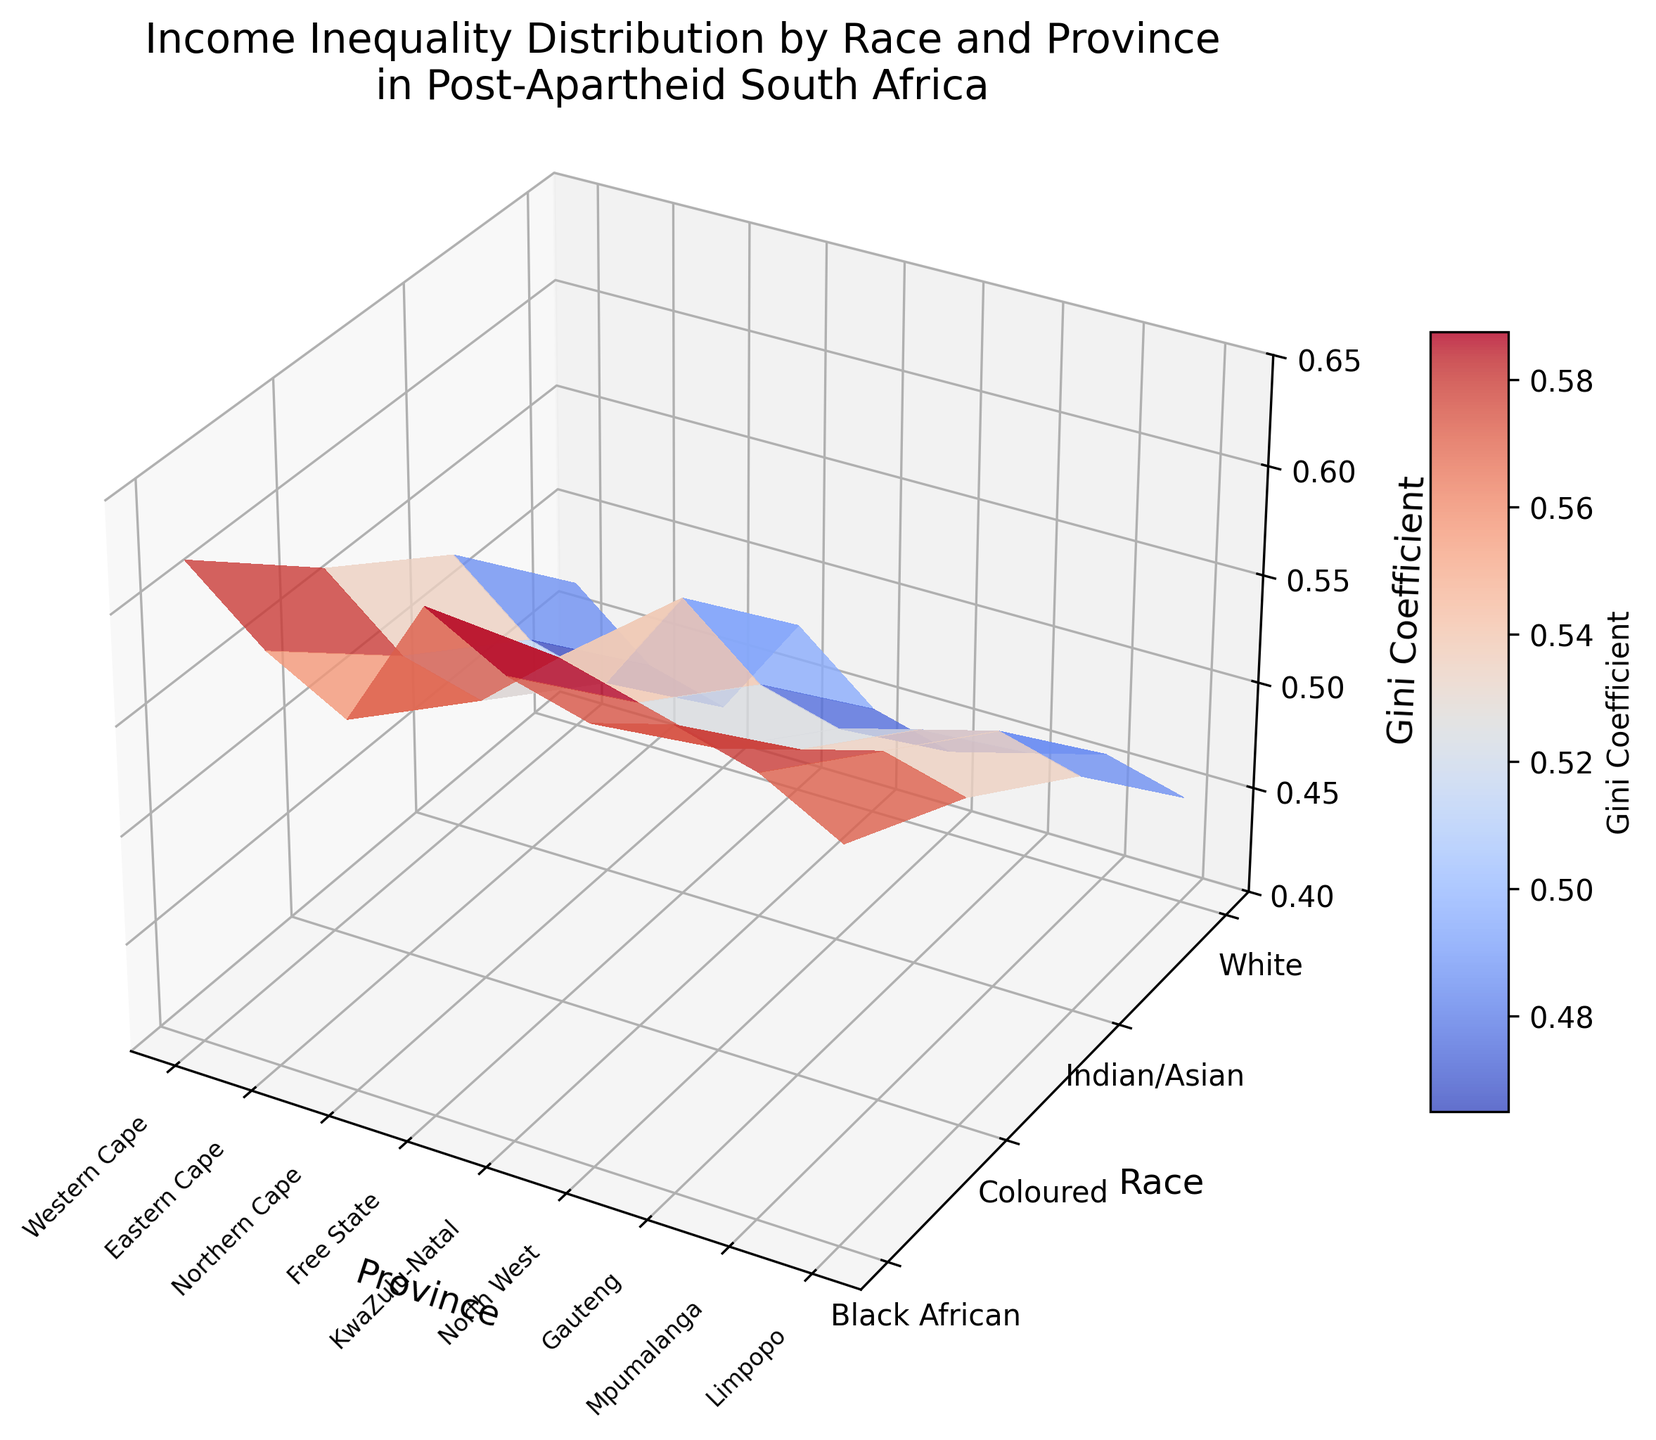What is the title of the plot? The title of the plot is written at the top center of the figure.
Answer: Income Inequality Distribution by Race and Province in Post-Apartheid South Africa What races are included in this analysis? The races included are listed along the Y-axis (Race axis) of the plot.
Answer: Black African, Coloured, Indian/Asian, White Which province shows the highest Gini Coefficient for Black Africans? Locate the points for Black Africans along the Y-axis and check the corresponding Z-axis values for each province. The highest value is in KwaZulu-Natal.
Answer: KwaZulu-Natal How does the Gini Coefficient for Whites in Gauteng compare to that in Western Cape? Locate the values for Whites along the Y-axis and compare the Z-axis values for Gauteng and Western Cape.
Answer: Lower in Gauteng What is the range of Gini Coefficient values displayed in the plot? The Z-axis label indicates the range, which is annotated from the minimum to the maximum value on the vertical scale.
Answer: 0.4 to 0.65 Are income inequalities higher for Indian/Asians or Coloureds in Free State? Compare the corresponding Z-axis values for Indian/Asians and Coloureds in Free State. Indian/Asians have a lower Gini Coefficient in Free State than Coloureds.
Answer: Coloureds What province has the lowest Gini Coefficient for White individuals? Identify the Z-axis values for Whites across all provinces. Gauteng displays the lowest value.
Answer: Gauteng Which race overall displays the highest income inequality? Compare the average height of the surface plot points along the Y-axis for each race. Black Africans show the highest overall Gini Coefficients.
Answer: Black Africans How much higher is the Gini Coefficient for Black Africans in Eastern Cape compared to Gauteng? Find the Z-axis values for Black Africans in both Eastern Cape and Gauteng, then subtract Gauteng's value from Eastern Cape's value: 0.62 - 0.57 = 0.05.
Answer: 0.05 In which province do Coloured individuals have a Gini Coefficient close to that of Indian/Asian individuals? Compare the Z-axis values for Coloureds and Indian/Asians in each province looking for similar values. In Limpopo, both have nearly identical Gini Coefficients of 0.55 and 0.51 respectively.
Answer: Limpopo 